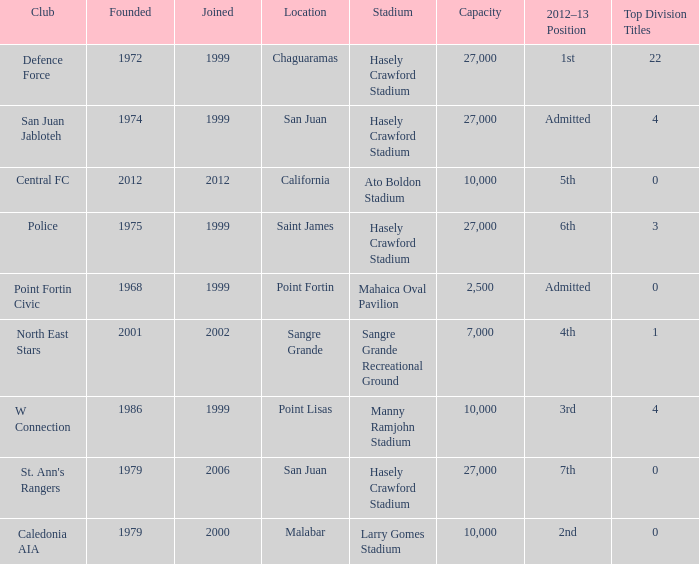Which stadium was used for the North East Stars club? Sangre Grande Recreational Ground. 